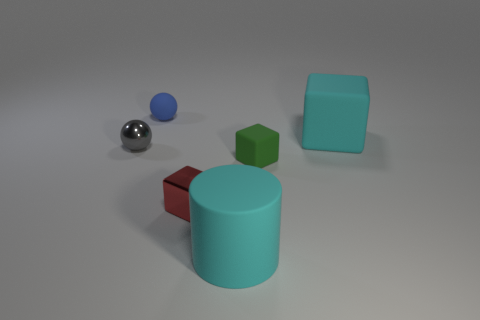Is the material of the large cube that is behind the green matte thing the same as the red thing?
Provide a short and direct response. No. There is a small blue thing; are there any red things behind it?
Your answer should be compact. No. What is the color of the rubber cube that is on the left side of the big rubber thing that is behind the small ball on the left side of the blue matte ball?
Provide a short and direct response. Green. What shape is the green object that is the same size as the gray shiny ball?
Your answer should be very brief. Cube. Is the number of tiny metal spheres greater than the number of brown shiny things?
Your response must be concise. Yes. There is a tiny thing that is on the left side of the matte ball; are there any metal things that are in front of it?
Your response must be concise. Yes. There is another tiny thing that is the same shape as the blue thing; what is its color?
Provide a succinct answer. Gray. What is the color of the tiny thing that is the same material as the red block?
Your answer should be compact. Gray. Is there a large rubber cylinder in front of the cyan object that is right of the big rubber thing that is left of the cyan rubber block?
Give a very brief answer. Yes. Are there fewer tiny red metallic objects in front of the red shiny block than small red blocks behind the green matte cube?
Keep it short and to the point. No. 